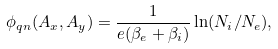Convert formula to latex. <formula><loc_0><loc_0><loc_500><loc_500>\phi _ { q n } ( A _ { x } , A _ { y } ) = \frac { 1 } { e ( \beta _ { e } + \beta _ { i } ) } \ln ( N _ { i } / N _ { e } ) ,</formula> 